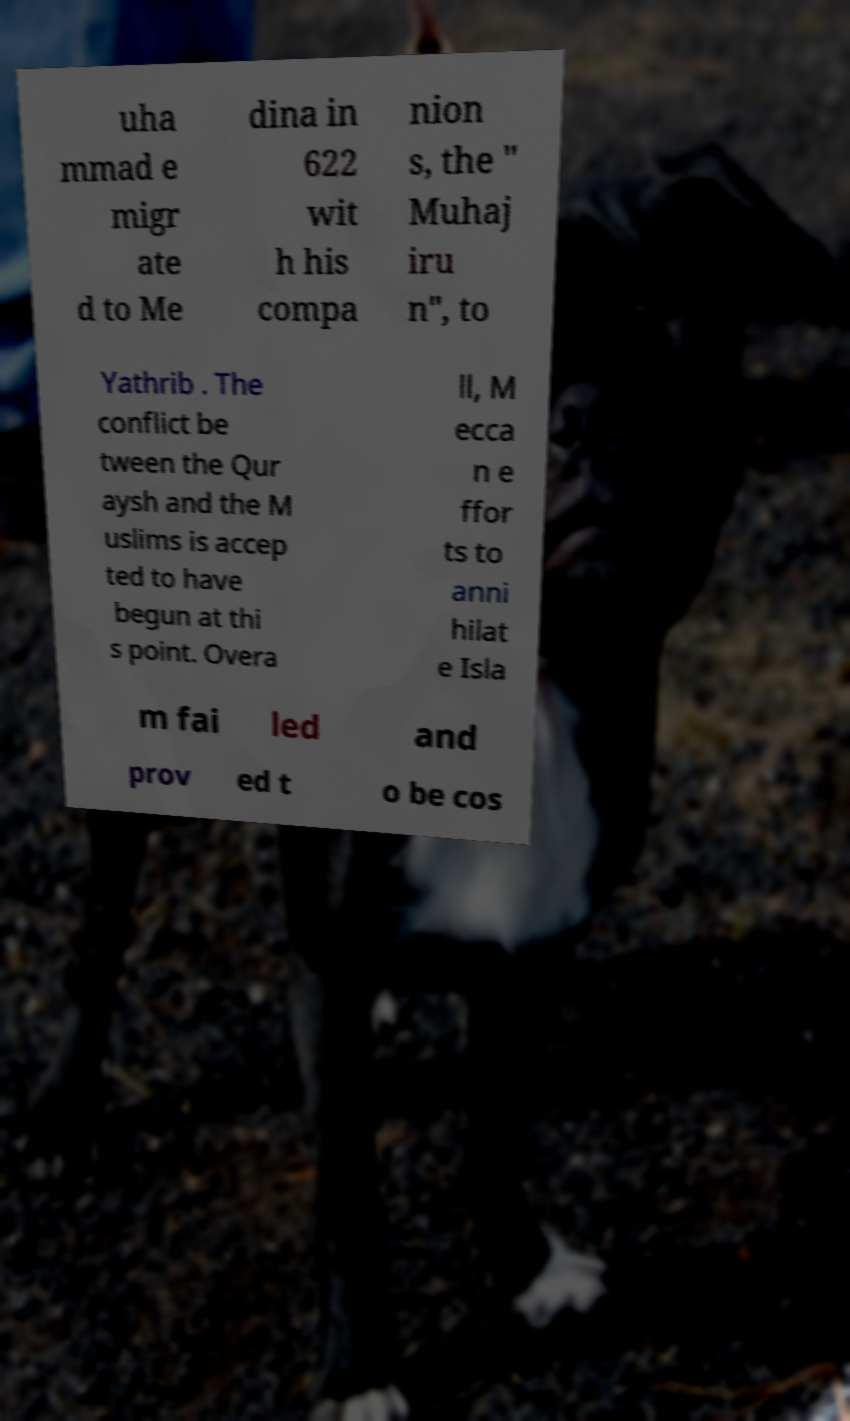Please read and relay the text visible in this image. What does it say? uha mmad e migr ate d to Me dina in 622 wit h his compa nion s, the " Muhaj iru n", to Yathrib . The conflict be tween the Qur aysh and the M uslims is accep ted to have begun at thi s point. Overa ll, M ecca n e ffor ts to anni hilat e Isla m fai led and prov ed t o be cos 